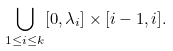Convert formula to latex. <formula><loc_0><loc_0><loc_500><loc_500>\bigcup _ { 1 \leq i \leq k } [ 0 , \lambda _ { i } ] \times [ i - 1 , i ] .</formula> 